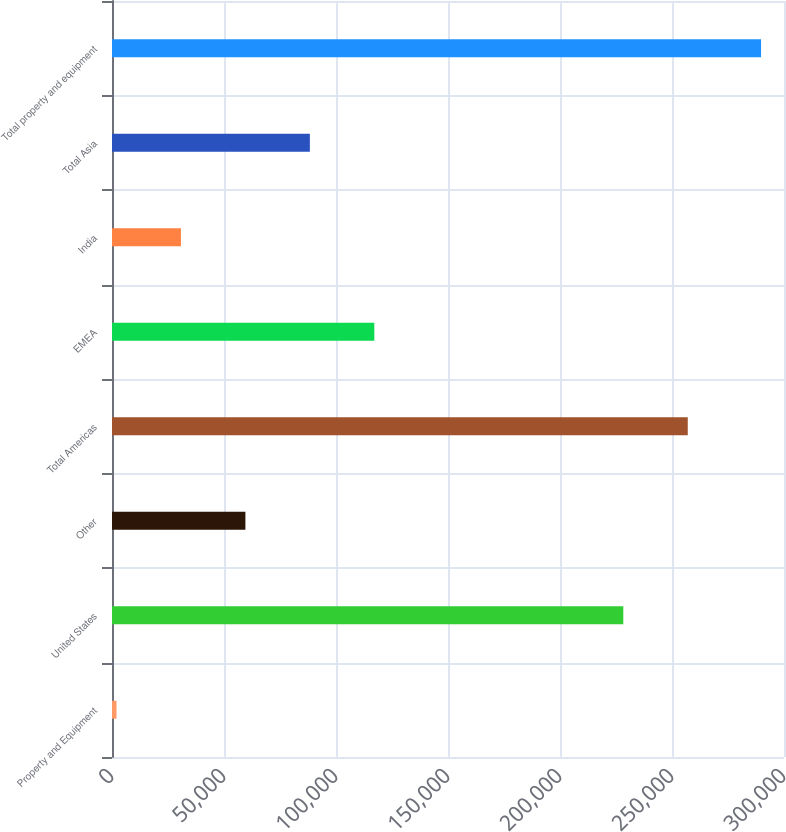Convert chart to OTSL. <chart><loc_0><loc_0><loc_500><loc_500><bar_chart><fcel>Property and Equipment<fcel>United States<fcel>Other<fcel>Total Americas<fcel>EMEA<fcel>India<fcel>Total Asia<fcel>Total property and equipment<nl><fcel>2007<fcel>228263<fcel>59557.2<fcel>257038<fcel>117107<fcel>30782.1<fcel>88332.3<fcel>289758<nl></chart> 